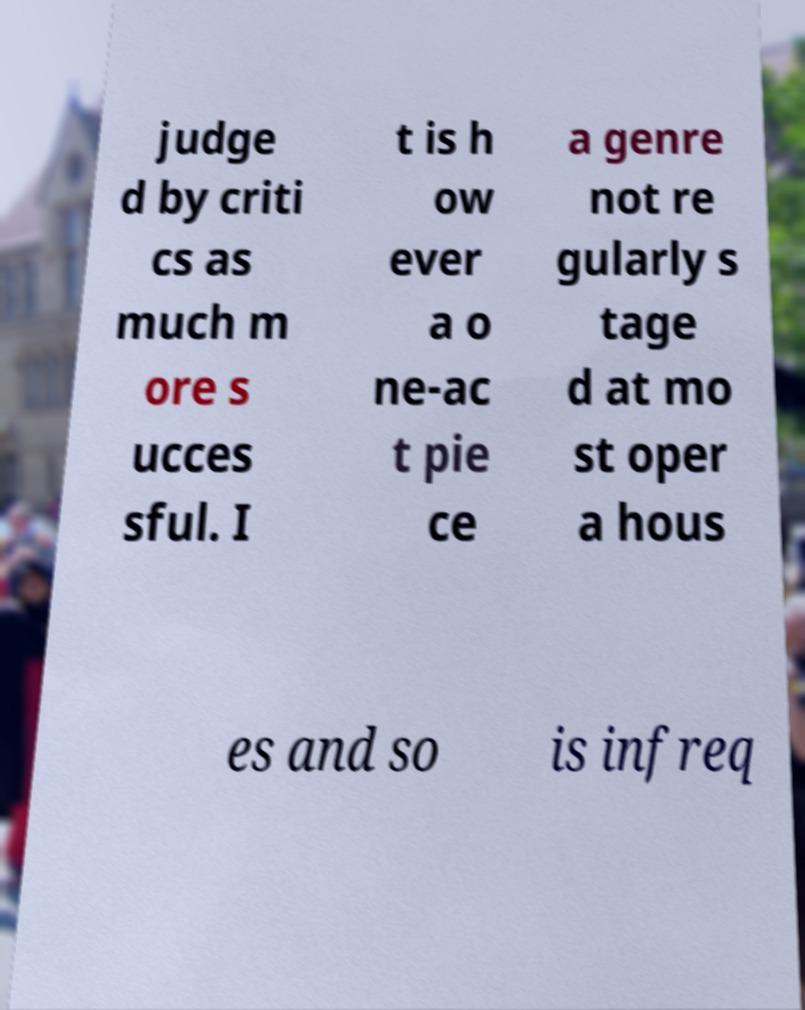Can you accurately transcribe the text from the provided image for me? judge d by criti cs as much m ore s ucces sful. I t is h ow ever a o ne-ac t pie ce a genre not re gularly s tage d at mo st oper a hous es and so is infreq 